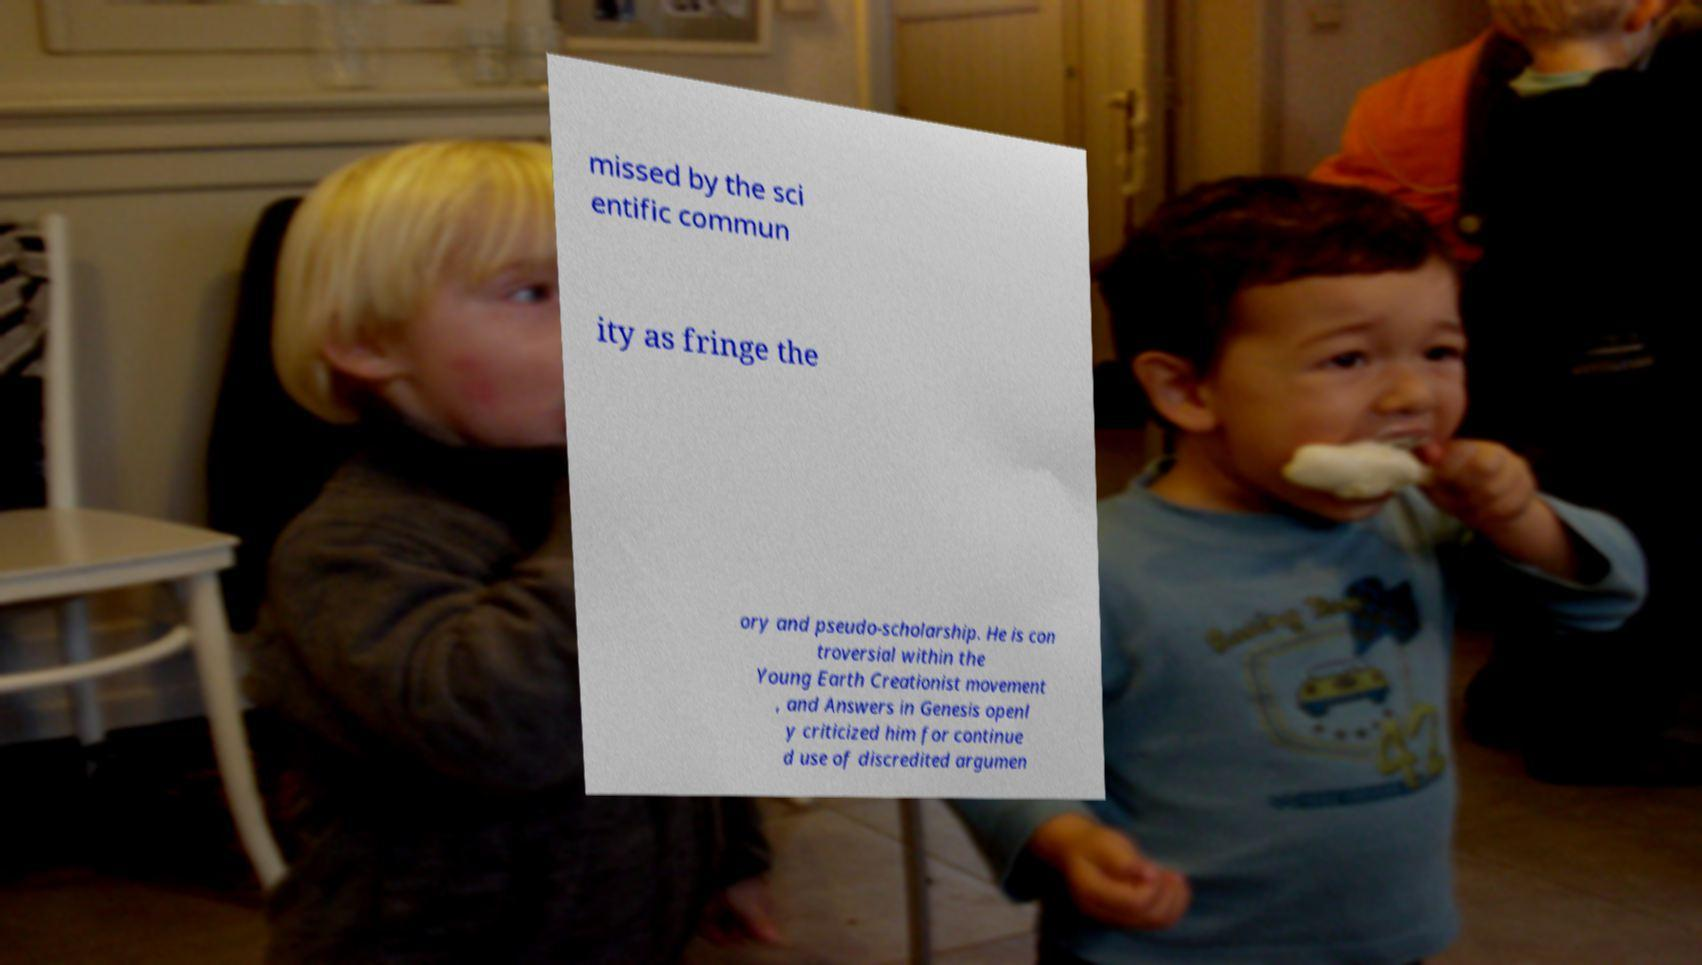Could you extract and type out the text from this image? missed by the sci entific commun ity as fringe the ory and pseudo-scholarship. He is con troversial within the Young Earth Creationist movement , and Answers in Genesis openl y criticized him for continue d use of discredited argumen 